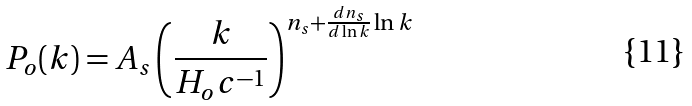Convert formula to latex. <formula><loc_0><loc_0><loc_500><loc_500>P _ { o } ( k ) = A _ { s } \left ( \frac { k } { H _ { o } c ^ { - 1 } } \right ) ^ { n _ { s } + \frac { d n _ { s } } { d \ln k } \ln k }</formula> 